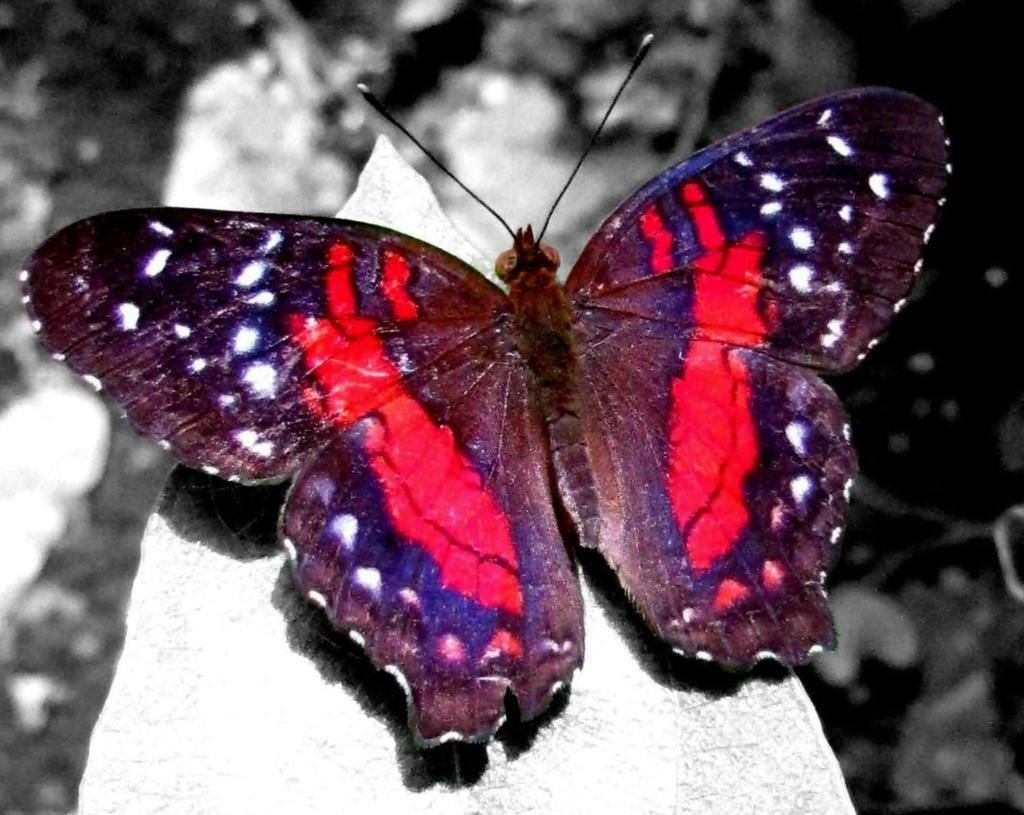What is the main subject of the image? The main subject of the image is a butterfly. Can you describe the appearance of the butterfly? The butterfly is beautiful and red in color. What type of camp can be seen in the background of the image? There is no camp present in the image; it features a beautiful red butterfly. How does the butterfly help with learning in the image? The butterfly does not contribute to learning in the image; it is simply a beautiful subject to observe. 